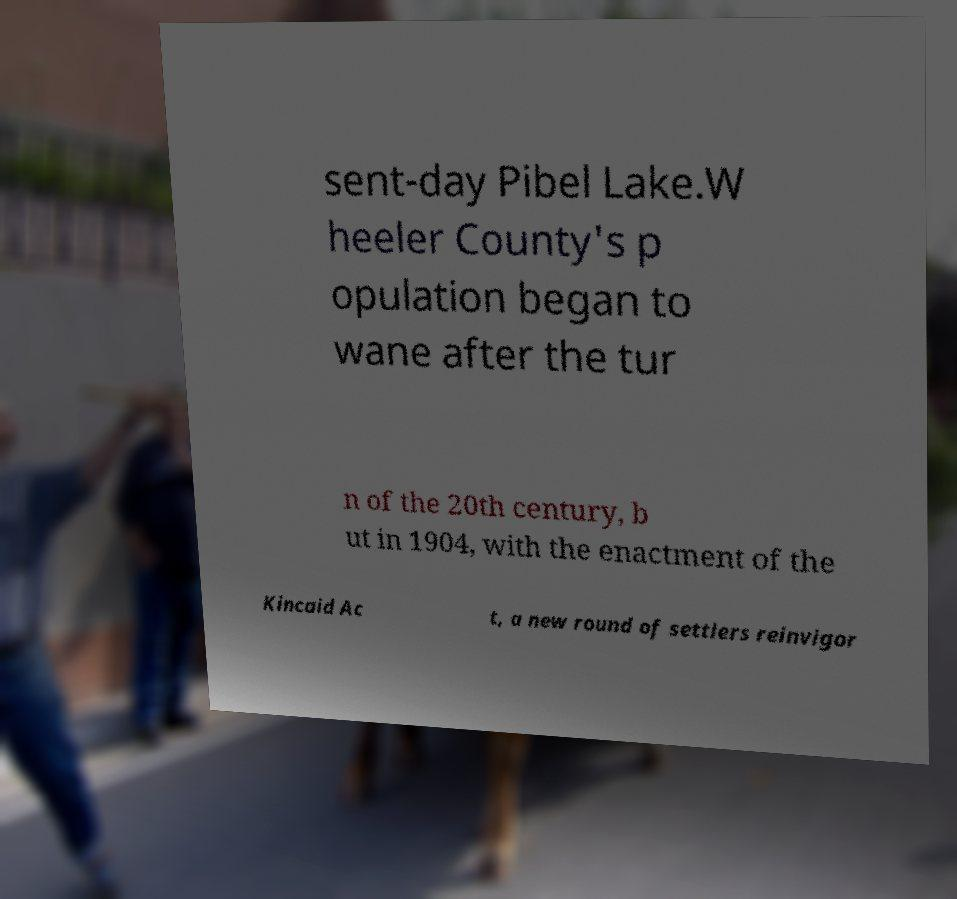For documentation purposes, I need the text within this image transcribed. Could you provide that? sent-day Pibel Lake.W heeler County's p opulation began to wane after the tur n of the 20th century, b ut in 1904, with the enactment of the Kincaid Ac t, a new round of settlers reinvigor 